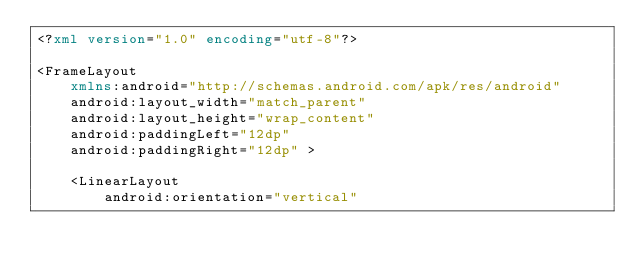<code> <loc_0><loc_0><loc_500><loc_500><_XML_><?xml version="1.0" encoding="utf-8"?>

<FrameLayout
    xmlns:android="http://schemas.android.com/apk/res/android"
    android:layout_width="match_parent"
    android:layout_height="wrap_content"
    android:paddingLeft="12dp"
    android:paddingRight="12dp" >

    <LinearLayout
        android:orientation="vertical"</code> 